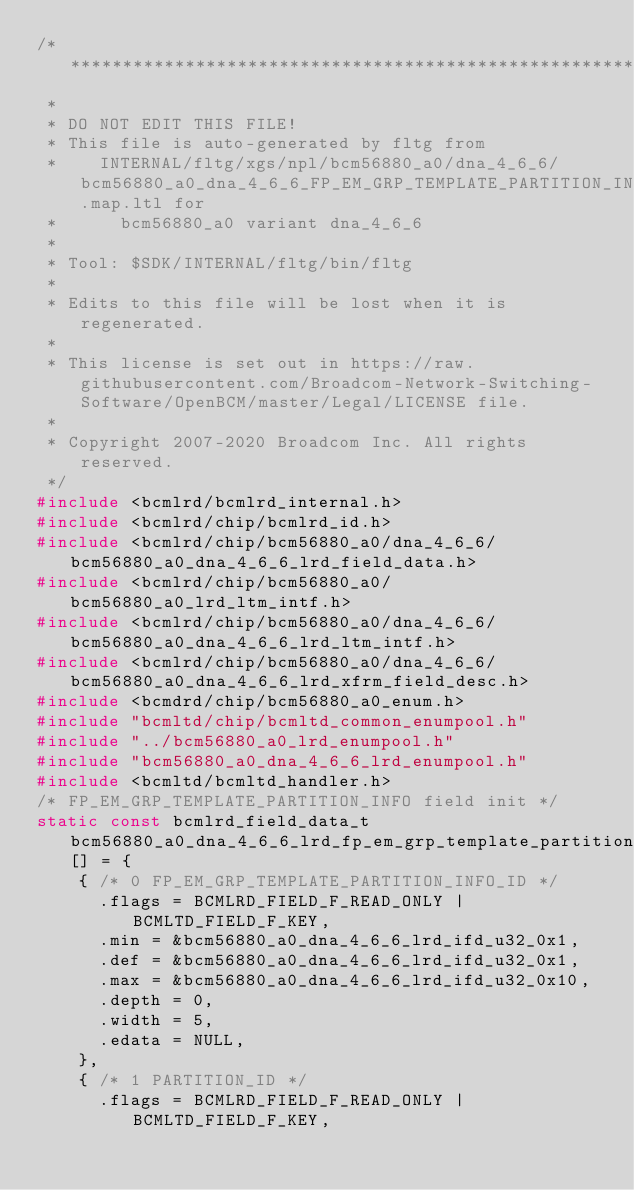Convert code to text. <code><loc_0><loc_0><loc_500><loc_500><_C_>/*******************************************************************************
 *
 * DO NOT EDIT THIS FILE!
 * This file is auto-generated by fltg from
 *    INTERNAL/fltg/xgs/npl/bcm56880_a0/dna_4_6_6/bcm56880_a0_dna_4_6_6_FP_EM_GRP_TEMPLATE_PARTITION_INFO.map.ltl for
 *      bcm56880_a0 variant dna_4_6_6
 *
 * Tool: $SDK/INTERNAL/fltg/bin/fltg
 *
 * Edits to this file will be lost when it is regenerated.
 *
 * This license is set out in https://raw.githubusercontent.com/Broadcom-Network-Switching-Software/OpenBCM/master/Legal/LICENSE file.
 * 
 * Copyright 2007-2020 Broadcom Inc. All rights reserved.
 */
#include <bcmlrd/bcmlrd_internal.h>
#include <bcmlrd/chip/bcmlrd_id.h>
#include <bcmlrd/chip/bcm56880_a0/dna_4_6_6/bcm56880_a0_dna_4_6_6_lrd_field_data.h>
#include <bcmlrd/chip/bcm56880_a0/bcm56880_a0_lrd_ltm_intf.h>
#include <bcmlrd/chip/bcm56880_a0/dna_4_6_6/bcm56880_a0_dna_4_6_6_lrd_ltm_intf.h>
#include <bcmlrd/chip/bcm56880_a0/dna_4_6_6/bcm56880_a0_dna_4_6_6_lrd_xfrm_field_desc.h>
#include <bcmdrd/chip/bcm56880_a0_enum.h>
#include "bcmltd/chip/bcmltd_common_enumpool.h"
#include "../bcm56880_a0_lrd_enumpool.h"
#include "bcm56880_a0_dna_4_6_6_lrd_enumpool.h"
#include <bcmltd/bcmltd_handler.h>
/* FP_EM_GRP_TEMPLATE_PARTITION_INFO field init */
static const bcmlrd_field_data_t bcm56880_a0_dna_4_6_6_lrd_fp_em_grp_template_partition_info_map_field_data_mmd[] = {
    { /* 0 FP_EM_GRP_TEMPLATE_PARTITION_INFO_ID */
      .flags = BCMLRD_FIELD_F_READ_ONLY | BCMLTD_FIELD_F_KEY,
      .min = &bcm56880_a0_dna_4_6_6_lrd_ifd_u32_0x1,
      .def = &bcm56880_a0_dna_4_6_6_lrd_ifd_u32_0x1,
      .max = &bcm56880_a0_dna_4_6_6_lrd_ifd_u32_0x10,
      .depth = 0,
      .width = 5,
      .edata = NULL,
    },
    { /* 1 PARTITION_ID */
      .flags = BCMLRD_FIELD_F_READ_ONLY | BCMLTD_FIELD_F_KEY,</code> 